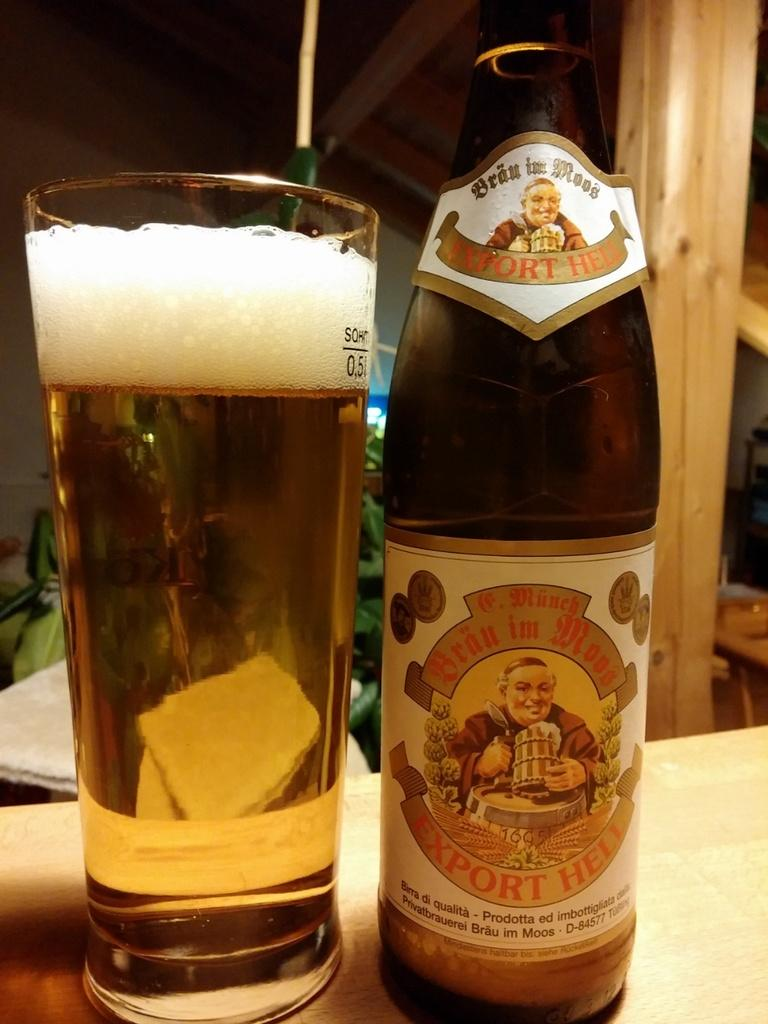<image>
Write a terse but informative summary of the picture. A bottle that says Export Heli next to a large glass of beer. 